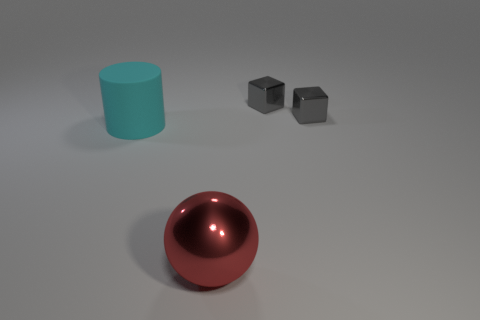Does the red sphere have the same material as the cylinder?
Keep it short and to the point. No. How many cyan cylinders are behind the large thing on the left side of the large red metallic sphere?
Provide a succinct answer. 0. Is there a large cyan matte thing of the same shape as the big metallic object?
Keep it short and to the point. No. Is the shape of the thing to the left of the large metallic thing the same as the big object that is in front of the big matte object?
Keep it short and to the point. No. Is there a red metallic sphere that has the same size as the red object?
Keep it short and to the point. No. There is a matte cylinder; is its color the same as the metallic thing that is in front of the matte thing?
Give a very brief answer. No. What is the cyan thing made of?
Provide a succinct answer. Rubber. The object that is in front of the cylinder is what color?
Make the answer very short. Red. What number of large rubber things are the same color as the big metallic ball?
Offer a very short reply. 0. How many things are both behind the big red object and right of the cylinder?
Give a very brief answer. 2. 